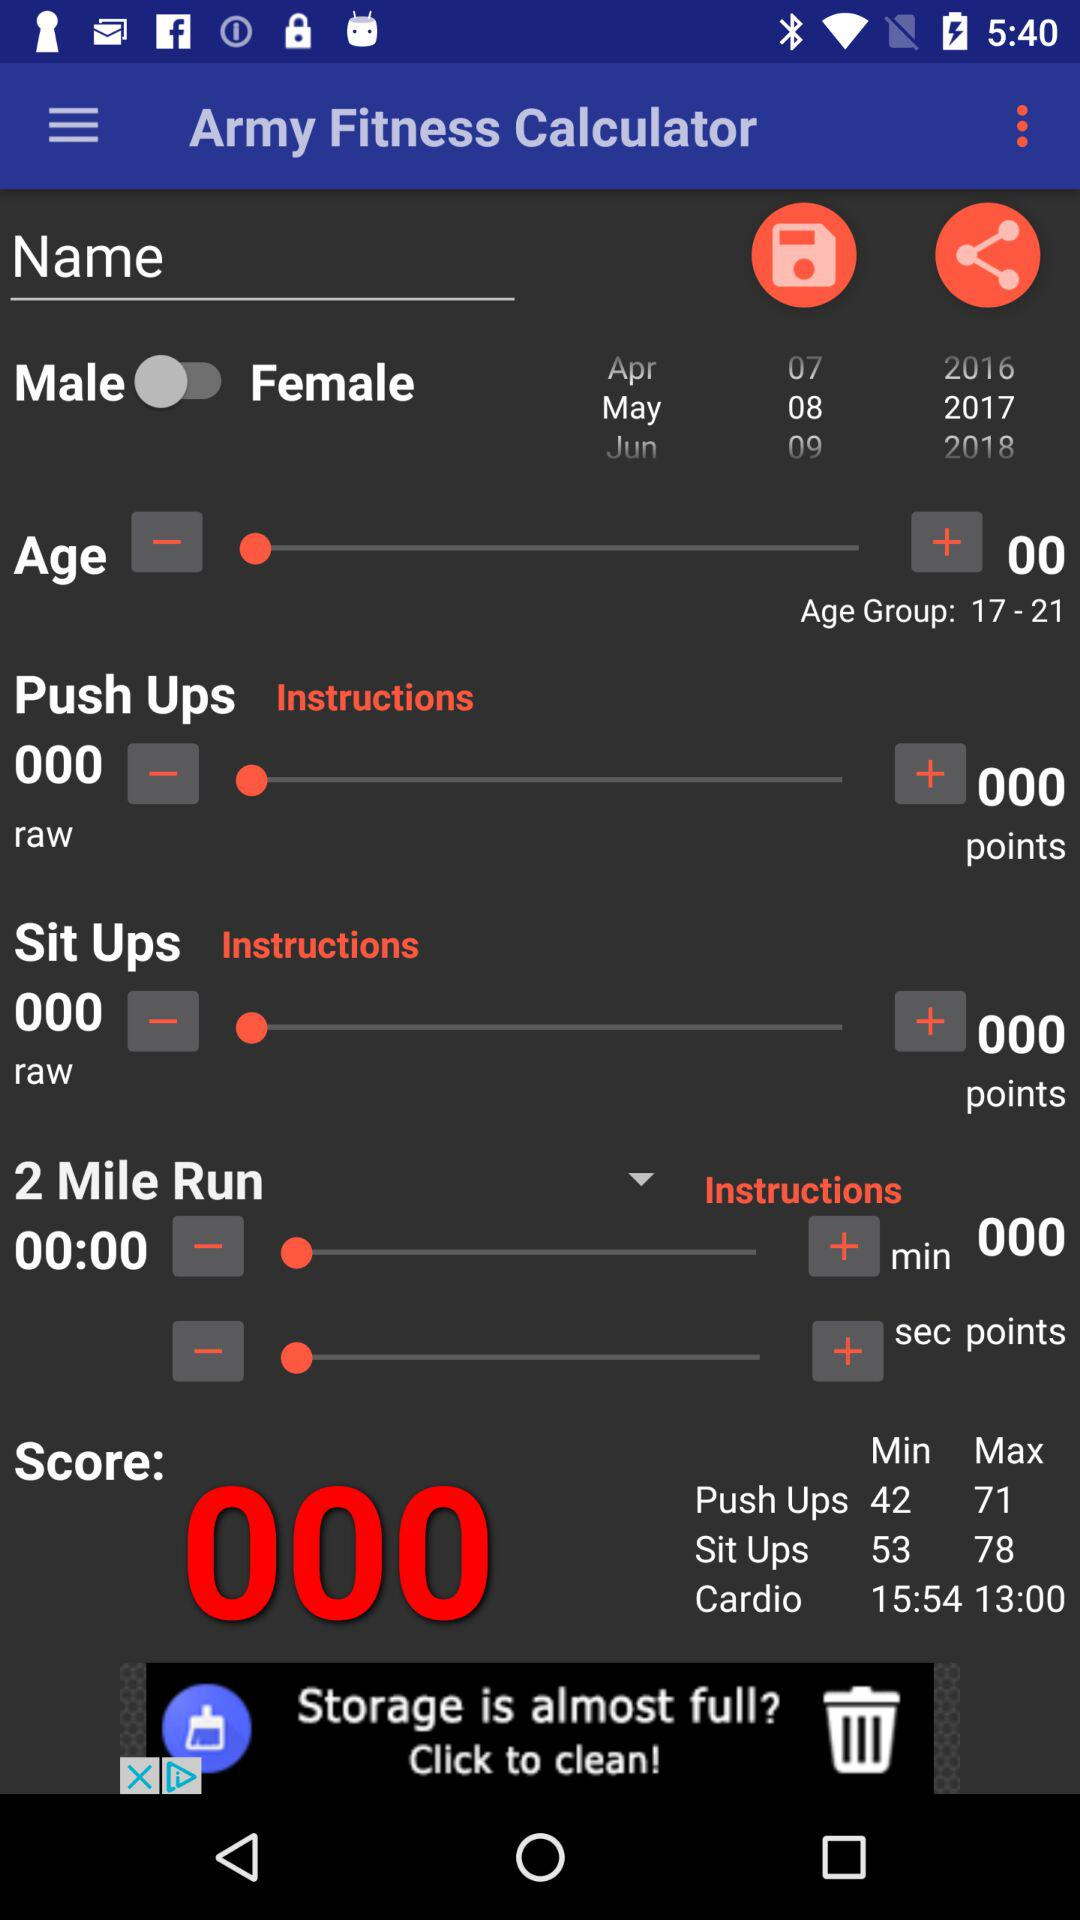What is the min. and max. number of push ups? The min. and max. number of push ups are 42 and 71, respectively. 